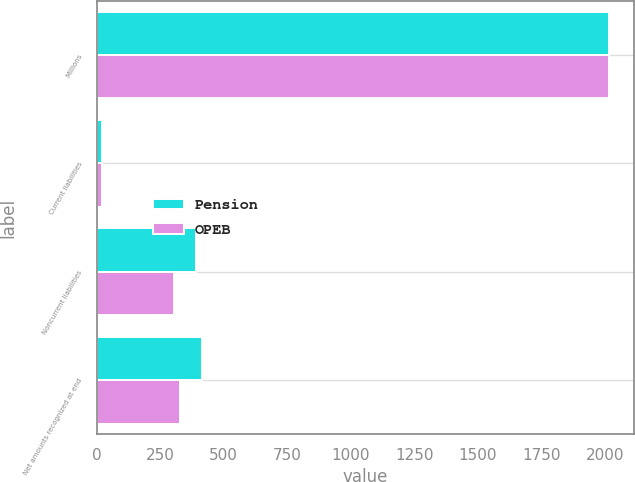Convert chart to OTSL. <chart><loc_0><loc_0><loc_500><loc_500><stacked_bar_chart><ecel><fcel>Millions<fcel>Current liabilities<fcel>Noncurrent liabilities<fcel>Net amounts recognized at end<nl><fcel>Pension<fcel>2015<fcel>22<fcel>393<fcel>414<nl><fcel>OPEB<fcel>2015<fcel>23<fcel>306<fcel>329<nl></chart> 